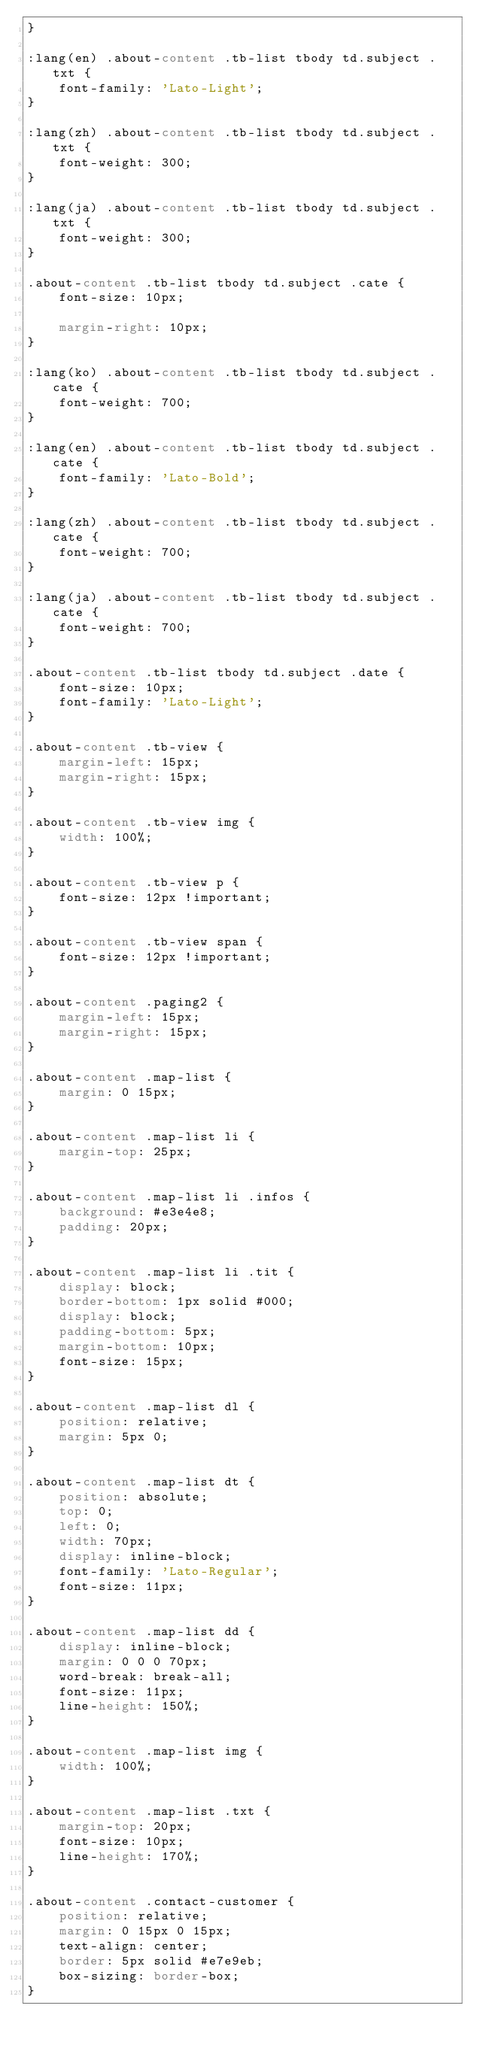<code> <loc_0><loc_0><loc_500><loc_500><_CSS_>}

:lang(en) .about-content .tb-list tbody td.subject .txt {
    font-family: 'Lato-Light';
}

:lang(zh) .about-content .tb-list tbody td.subject .txt {
    font-weight: 300;
}

:lang(ja) .about-content .tb-list tbody td.subject .txt {
    font-weight: 300;
}

.about-content .tb-list tbody td.subject .cate {
    font-size: 10px;

    margin-right: 10px;
}

:lang(ko) .about-content .tb-list tbody td.subject .cate {
    font-weight: 700;
}

:lang(en) .about-content .tb-list tbody td.subject .cate {
    font-family: 'Lato-Bold';
}

:lang(zh) .about-content .tb-list tbody td.subject .cate {
    font-weight: 700;
}

:lang(ja) .about-content .tb-list tbody td.subject .cate {
    font-weight: 700;
}

.about-content .tb-list tbody td.subject .date {
    font-size: 10px;
    font-family: 'Lato-Light';
}

.about-content .tb-view {
    margin-left: 15px;
    margin-right: 15px;
}

.about-content .tb-view img {
    width: 100%;
}

.about-content .tb-view p {
    font-size: 12px !important;
}

.about-content .tb-view span {
    font-size: 12px !important;
}

.about-content .paging2 {
    margin-left: 15px;
    margin-right: 15px;
}

.about-content .map-list {
    margin: 0 15px;
}

.about-content .map-list li {
    margin-top: 25px;
}

.about-content .map-list li .infos {
    background: #e3e4e8;
    padding: 20px;
}

.about-content .map-list li .tit {
    display: block;
    border-bottom: 1px solid #000;
    display: block;
    padding-bottom: 5px;
    margin-bottom: 10px;
    font-size: 15px;
}

.about-content .map-list dl {
    position: relative;
    margin: 5px 0;
}

.about-content .map-list dt {
    position: absolute;
    top: 0;
    left: 0;
    width: 70px;
    display: inline-block;
    font-family: 'Lato-Regular';
    font-size: 11px;
}

.about-content .map-list dd {
    display: inline-block;
    margin: 0 0 0 70px;
    word-break: break-all;
    font-size: 11px;
    line-height: 150%;
}

.about-content .map-list img {
    width: 100%;
}

.about-content .map-list .txt {
    margin-top: 20px;
    font-size: 10px;
    line-height: 170%;
}

.about-content .contact-customer {
    position: relative;
    margin: 0 15px 0 15px;
    text-align: center;
    border: 5px solid #e7e9eb;
    box-sizing: border-box;
}
</code> 